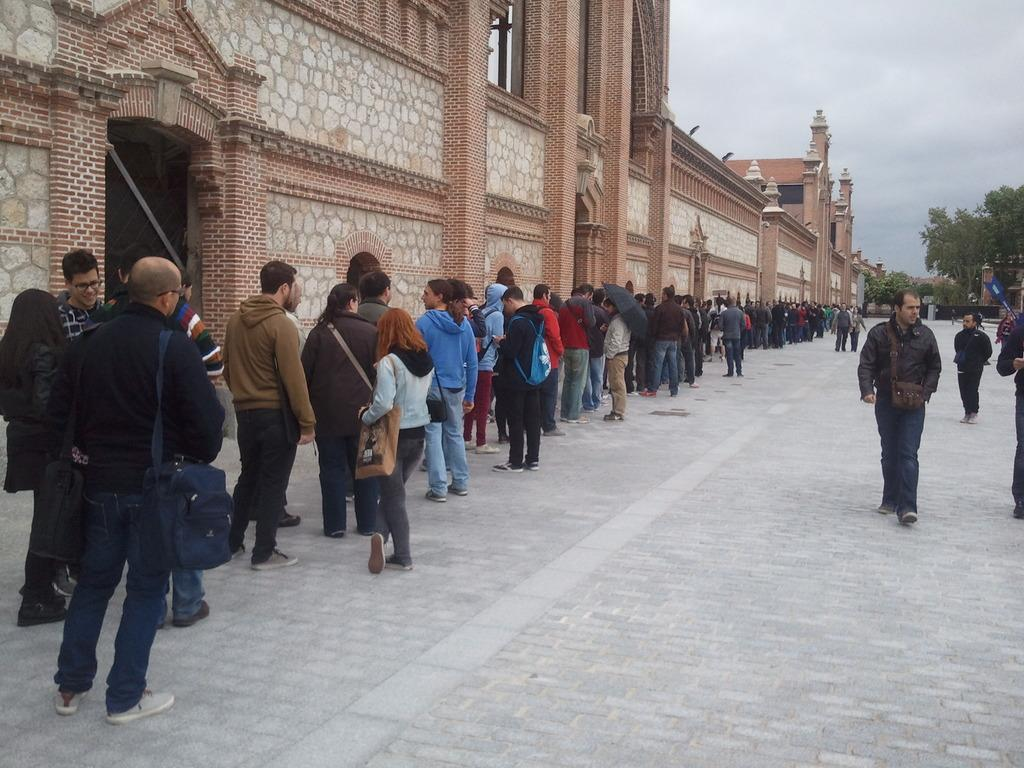What is the main structure in the image? There is a building in the image. What is happening in front of the building? There are many people standing in front of the building. What can be seen in the background to the right? There are trees in the background to the right. What is visible at the top of the image? The sky is visible at the top of the image. What channel is being broadcasted on the building's television in the image? There is no television or channel mentioned in the image; it only features a building, people, trees, and the sky. 